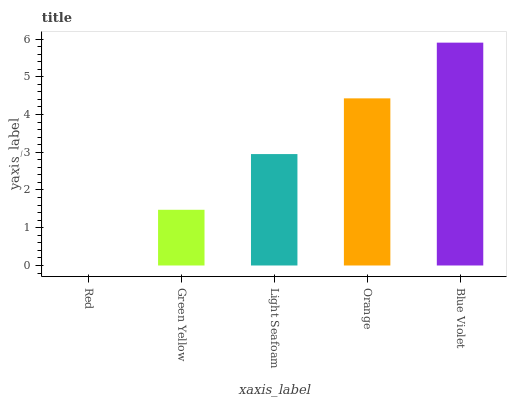Is Red the minimum?
Answer yes or no. Yes. Is Blue Violet the maximum?
Answer yes or no. Yes. Is Green Yellow the minimum?
Answer yes or no. No. Is Green Yellow the maximum?
Answer yes or no. No. Is Green Yellow greater than Red?
Answer yes or no. Yes. Is Red less than Green Yellow?
Answer yes or no. Yes. Is Red greater than Green Yellow?
Answer yes or no. No. Is Green Yellow less than Red?
Answer yes or no. No. Is Light Seafoam the high median?
Answer yes or no. Yes. Is Light Seafoam the low median?
Answer yes or no. Yes. Is Red the high median?
Answer yes or no. No. Is Green Yellow the low median?
Answer yes or no. No. 